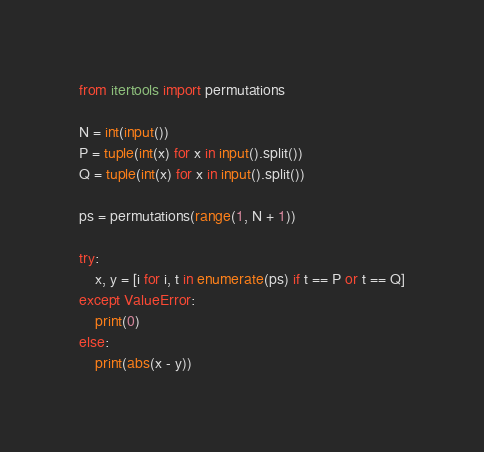<code> <loc_0><loc_0><loc_500><loc_500><_Python_>from itertools import permutations

N = int(input())
P = tuple(int(x) for x in input().split())
Q = tuple(int(x) for x in input().split())

ps = permutations(range(1, N + 1))

try:
    x, y = [i for i, t in enumerate(ps) if t == P or t == Q]
except ValueError:
    print(0)
else:
    print(abs(x - y))
</code> 